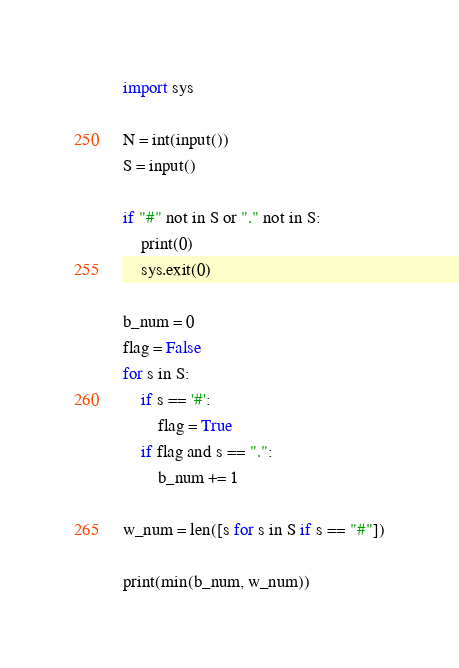Convert code to text. <code><loc_0><loc_0><loc_500><loc_500><_Python_>import sys

N = int(input())
S = input()

if "#" not in S or "." not in S:
    print(0)
    sys.exit(0)

b_num = 0
flag = False
for s in S:
    if s == '#':
        flag = True
    if flag and s == ".":
        b_num += 1

w_num = len([s for s in S if s == "#"])

print(min(b_num, w_num))
</code> 